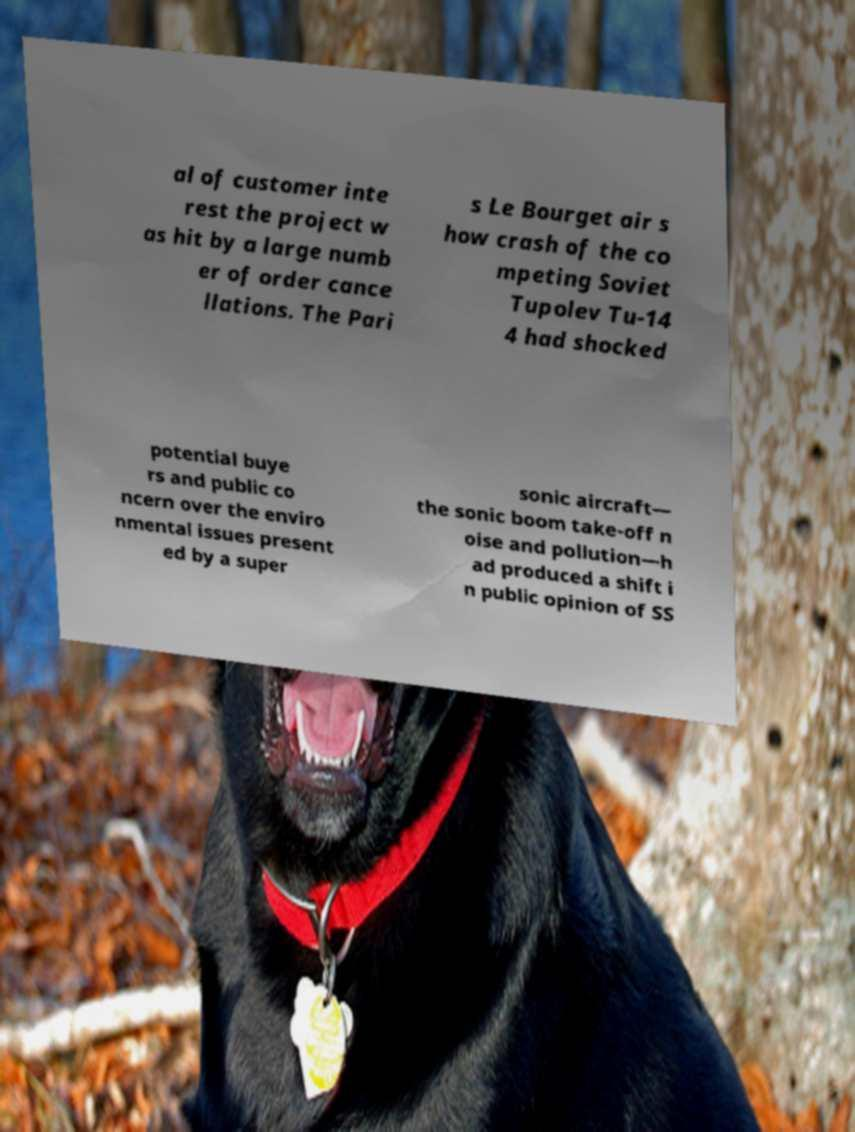What messages or text are displayed in this image? I need them in a readable, typed format. al of customer inte rest the project w as hit by a large numb er of order cance llations. The Pari s Le Bourget air s how crash of the co mpeting Soviet Tupolev Tu-14 4 had shocked potential buye rs and public co ncern over the enviro nmental issues present ed by a super sonic aircraft— the sonic boom take-off n oise and pollution—h ad produced a shift i n public opinion of SS 